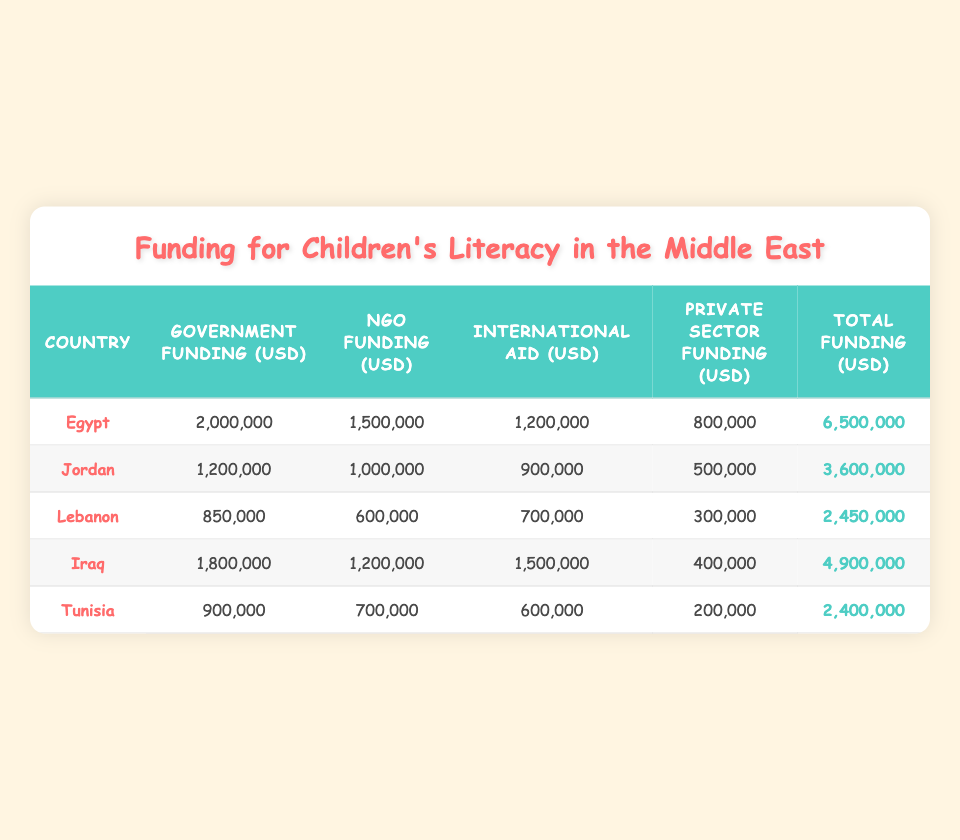What is the total funding for children's literacy programs in Egypt? The total funding for children's literacy programs in Egypt is listed in the last column. The number provided is 6,500,000 USD.
Answer: 6,500,000 USD What is the amount of NGO funding in Jordan? The NGO funding for Jordan is found in the second column of the row labeled Jordan. The value listed is 1,000,000 USD.
Answer: 1,000,000 USD Does Lebanon receive more government funding than Tunisia? The government funding for Lebanon is 850,000 USD, while Tunisia receives 900,000 USD. Thus, Lebanon does not receive more government funding than Tunisia, making the statement false.
Answer: No Which country has the highest total funding for children's literacy programs? To determine the country with the highest total funding, we compare all total funding values: Egypt (6,500,000), Iraq (4,900,000), Jordan (3,600,000), Lebanon (2,450,000), and Tunisia (2,400,000). Egypt has the highest value at 6,500,000 USD.
Answer: Egypt What is the sum of private sector funding for all listed countries? We find the private sector funding for each country: Egypt (800,000), Jordan (500,000), Lebanon (300,000), Iraq (400,000), and Tunisia (200,000). The total sum is 800,000 + 500,000 + 300,000 + 400,000 + 200,000 = 2,200,000 USD.
Answer: 2,200,000 USD Is the international aid for Iraq greater than that for Egypt? The international aid for Iraq is 1,500,000 USD and for Egypt is 1,200,000 USD. Since 1,500,000 is greater than 1,200,000, the statement is true.
Answer: Yes What is the average government funding across all five countries? The government funding values are: Egypt (2,000,000), Jordan (1,200,000), Lebanon (850,000), Iraq (1,800,000), and Tunisia (900,000). The total is 2,000,000 + 1,200,000 + 850,000 + 1,800,000 + 900,000 = 6,750,000. To find the average, we divide by 5: 6,750,000 / 5 = 1,350,000 USD.
Answer: 1,350,000 USD Which country has the least amount of total funding? By identifying the total funding for each country: Egypt (6,500,000), Iraq (4,900,000), Jordan (3,600,000), Lebanon (2,450,000), and Tunisia (2,400,000), we see that Tunisia has the least amount of total funding at 2,400,000 USD.
Answer: Tunisia 